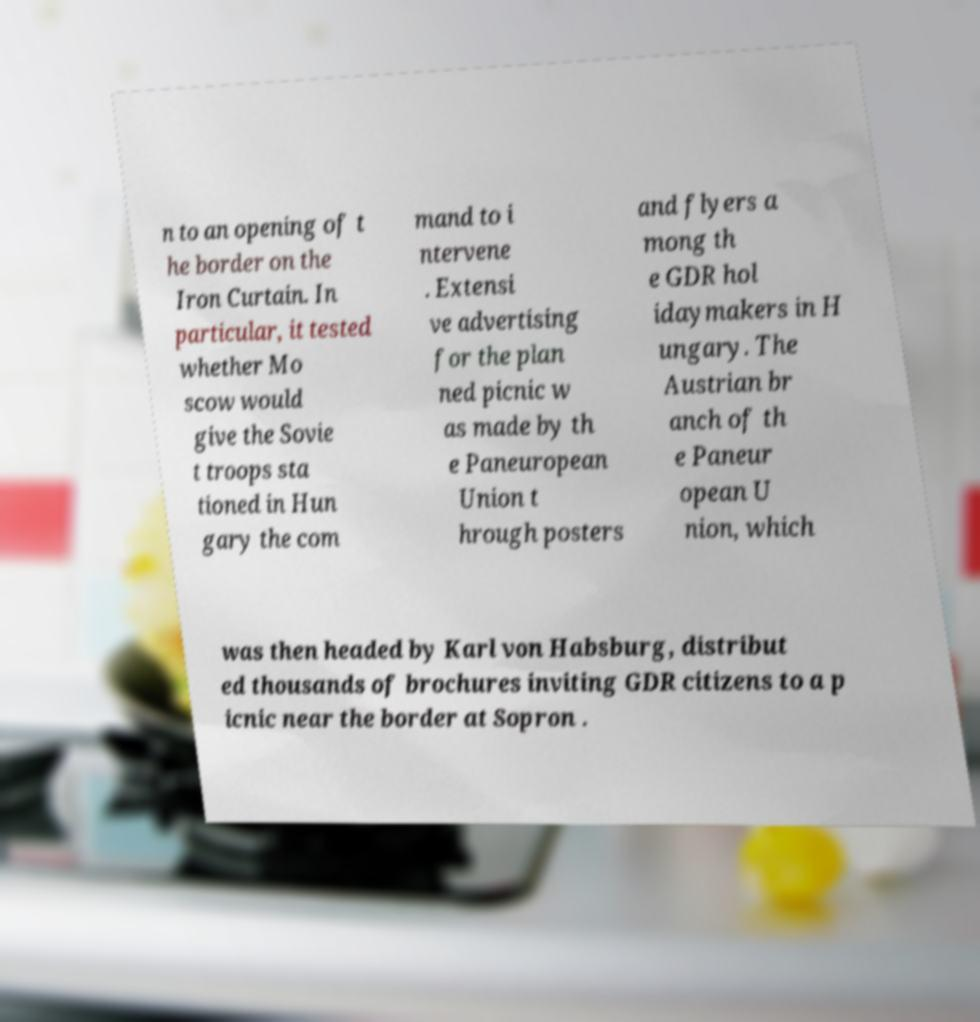Could you assist in decoding the text presented in this image and type it out clearly? n to an opening of t he border on the Iron Curtain. In particular, it tested whether Mo scow would give the Sovie t troops sta tioned in Hun gary the com mand to i ntervene . Extensi ve advertising for the plan ned picnic w as made by th e Paneuropean Union t hrough posters and flyers a mong th e GDR hol idaymakers in H ungary. The Austrian br anch of th e Paneur opean U nion, which was then headed by Karl von Habsburg, distribut ed thousands of brochures inviting GDR citizens to a p icnic near the border at Sopron . 